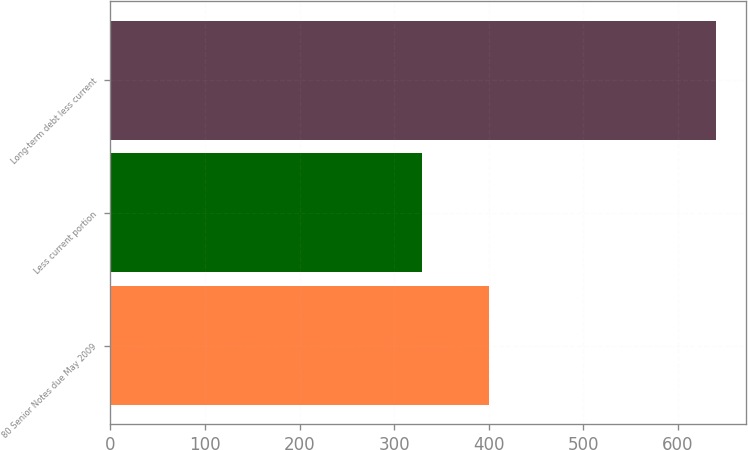Convert chart. <chart><loc_0><loc_0><loc_500><loc_500><bar_chart><fcel>80 Senior Notes due May 2009<fcel>Less current portion<fcel>Long-term debt less current<nl><fcel>400<fcel>330<fcel>640<nl></chart> 